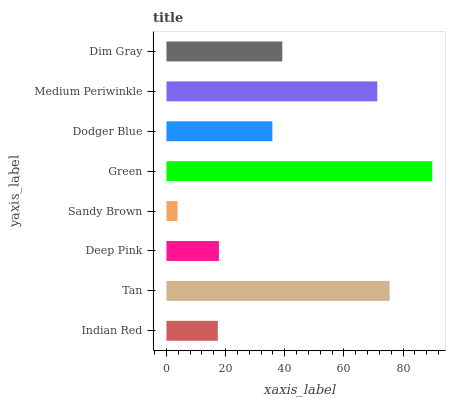Is Sandy Brown the minimum?
Answer yes or no. Yes. Is Green the maximum?
Answer yes or no. Yes. Is Tan the minimum?
Answer yes or no. No. Is Tan the maximum?
Answer yes or no. No. Is Tan greater than Indian Red?
Answer yes or no. Yes. Is Indian Red less than Tan?
Answer yes or no. Yes. Is Indian Red greater than Tan?
Answer yes or no. No. Is Tan less than Indian Red?
Answer yes or no. No. Is Dim Gray the high median?
Answer yes or no. Yes. Is Dodger Blue the low median?
Answer yes or no. Yes. Is Dodger Blue the high median?
Answer yes or no. No. Is Dim Gray the low median?
Answer yes or no. No. 